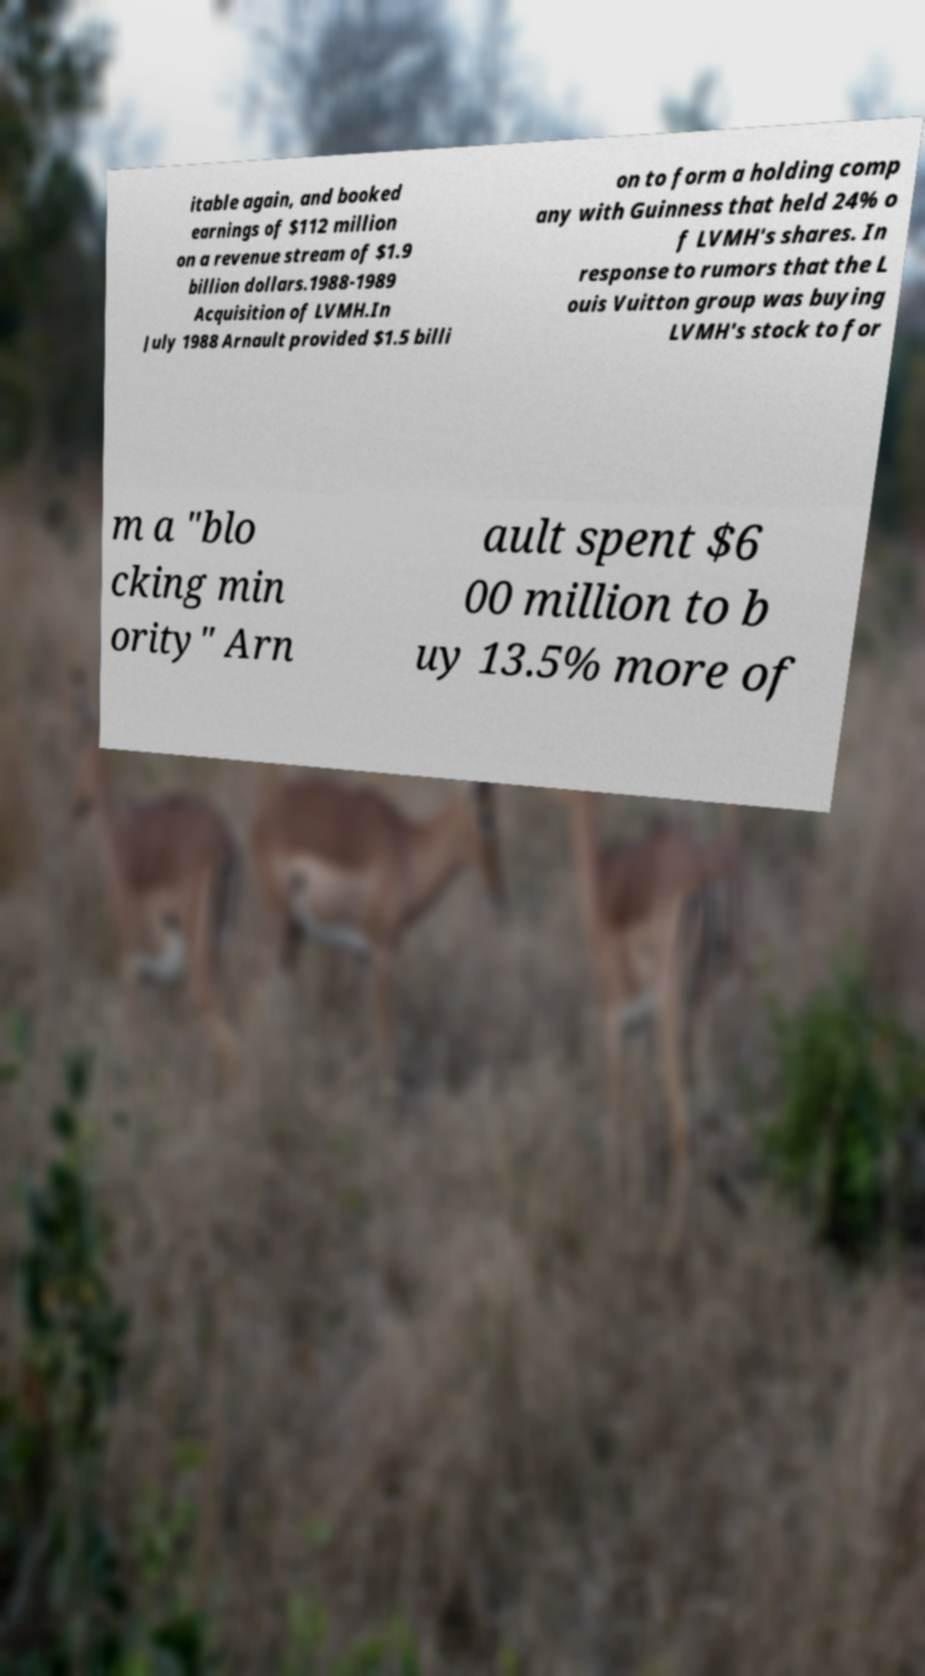Can you read and provide the text displayed in the image?This photo seems to have some interesting text. Can you extract and type it out for me? itable again, and booked earnings of $112 million on a revenue stream of $1.9 billion dollars.1988-1989 Acquisition of LVMH.In July 1988 Arnault provided $1.5 billi on to form a holding comp any with Guinness that held 24% o f LVMH's shares. In response to rumors that the L ouis Vuitton group was buying LVMH's stock to for m a "blo cking min ority" Arn ault spent $6 00 million to b uy 13.5% more of 